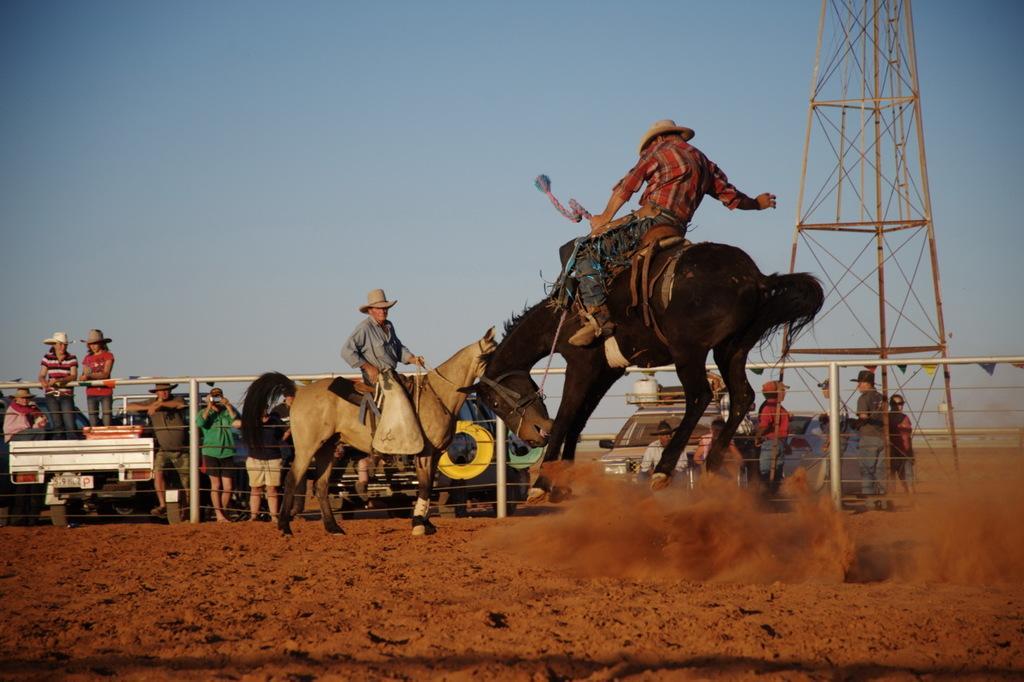Describe this image in one or two sentences. This image is taken outdoors. At the bottom of the image there is a ground. At the top of the image there is the sky. On the right side of the image there is a tower and a few people are standing on the ground. In the background there is a railing. A few vehicles are parked on the ground and a few people are standing on the ground. A few are sitting and a few are standing in the vehicles. In the middle of the image two men are riding on the horses. 